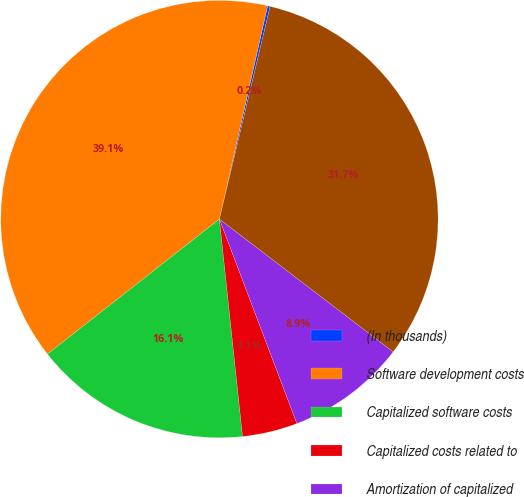<chart> <loc_0><loc_0><loc_500><loc_500><pie_chart><fcel>(In thousands)<fcel>Software development costs<fcel>Capitalized software costs<fcel>Capitalized costs related to<fcel>Amortization of capitalized<fcel>Total software development<nl><fcel>0.19%<fcel>39.13%<fcel>16.09%<fcel>4.08%<fcel>8.85%<fcel>31.66%<nl></chart> 